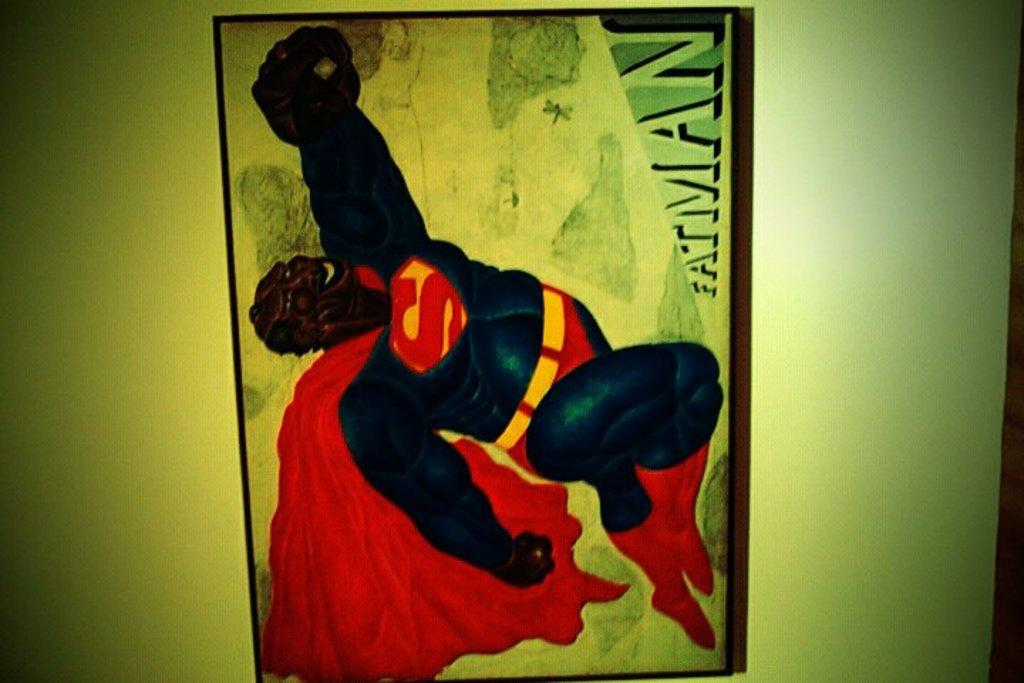<image>
Offer a succinct explanation of the picture presented. An illustration that says Fatman but has a superman costume. 